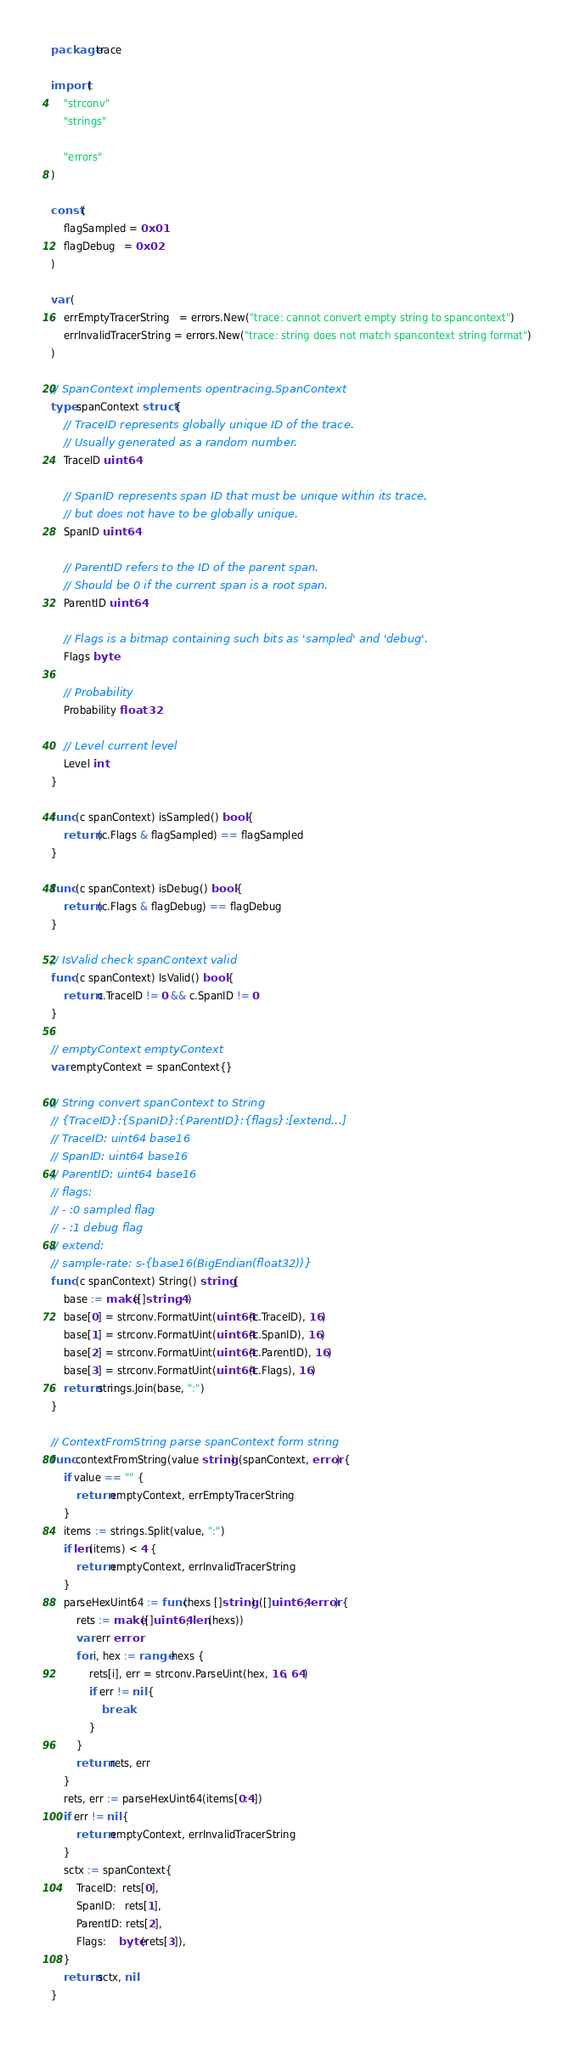Convert code to text. <code><loc_0><loc_0><loc_500><loc_500><_Go_>package trace

import (
	"strconv"
	"strings"

	"errors"
)

const (
	flagSampled = 0x01
	flagDebug   = 0x02
)

var (
	errEmptyTracerString   = errors.New("trace: cannot convert empty string to spancontext")
	errInvalidTracerString = errors.New("trace: string does not match spancontext string format")
)

// SpanContext implements opentracing.SpanContext
type spanContext struct {
	// TraceID represents globally unique ID of the trace.
	// Usually generated as a random number.
	TraceID uint64

	// SpanID represents span ID that must be unique within its trace,
	// but does not have to be globally unique.
	SpanID uint64

	// ParentID refers to the ID of the parent span.
	// Should be 0 if the current span is a root span.
	ParentID uint64

	// Flags is a bitmap containing such bits as 'sampled' and 'debug'.
	Flags byte

	// Probability
	Probability float32

	// Level current level
	Level int
}

func (c spanContext) isSampled() bool {
	return (c.Flags & flagSampled) == flagSampled
}

func (c spanContext) isDebug() bool {
	return (c.Flags & flagDebug) == flagDebug
}

// IsValid check spanContext valid
func (c spanContext) IsValid() bool {
	return c.TraceID != 0 && c.SpanID != 0
}

// emptyContext emptyContext
var emptyContext = spanContext{}

// String convert spanContext to String
// {TraceID}:{SpanID}:{ParentID}:{flags}:[extend...]
// TraceID: uint64 base16
// SpanID: uint64 base16
// ParentID: uint64 base16
// flags:
// - :0 sampled flag
// - :1 debug flag
// extend:
// sample-rate: s-{base16(BigEndian(float32))}
func (c spanContext) String() string {
	base := make([]string, 4)
	base[0] = strconv.FormatUint(uint64(c.TraceID), 16)
	base[1] = strconv.FormatUint(uint64(c.SpanID), 16)
	base[2] = strconv.FormatUint(uint64(c.ParentID), 16)
	base[3] = strconv.FormatUint(uint64(c.Flags), 16)
	return strings.Join(base, ":")
}

// ContextFromString parse spanContext form string
func contextFromString(value string) (spanContext, error) {
	if value == "" {
		return emptyContext, errEmptyTracerString
	}
	items := strings.Split(value, ":")
	if len(items) < 4 {
		return emptyContext, errInvalidTracerString
	}
	parseHexUint64 := func(hexs []string) ([]uint64, error) {
		rets := make([]uint64, len(hexs))
		var err error
		for i, hex := range hexs {
			rets[i], err = strconv.ParseUint(hex, 16, 64)
			if err != nil {
				break
			}
		}
		return rets, err
	}
	rets, err := parseHexUint64(items[0:4])
	if err != nil {
		return emptyContext, errInvalidTracerString
	}
	sctx := spanContext{
		TraceID:  rets[0],
		SpanID:   rets[1],
		ParentID: rets[2],
		Flags:    byte(rets[3]),
	}
	return sctx, nil
}
</code> 